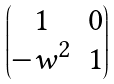<formula> <loc_0><loc_0><loc_500><loc_500>\begin{pmatrix} 1 & 0 \\ - w ^ { 2 } & 1 \end{pmatrix}</formula> 